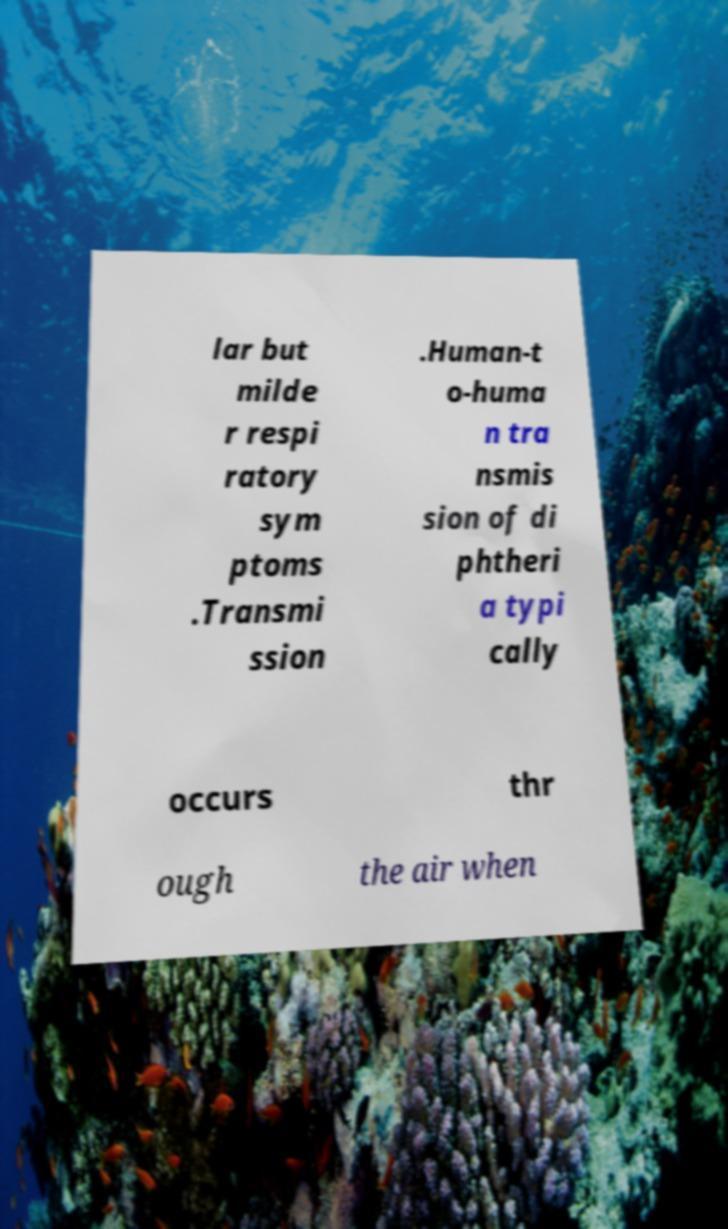Could you extract and type out the text from this image? lar but milde r respi ratory sym ptoms .Transmi ssion .Human-t o-huma n tra nsmis sion of di phtheri a typi cally occurs thr ough the air when 